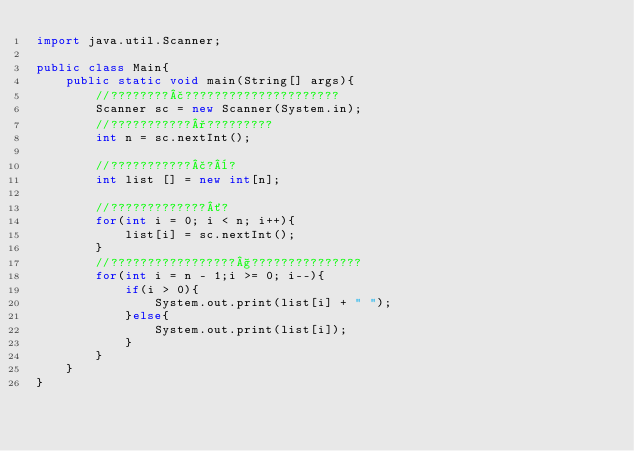<code> <loc_0><loc_0><loc_500><loc_500><_Java_>import java.util.Scanner;

public class Main{
	public static void main(String[] args){
		//????????£?????????????????????
		Scanner sc = new Scanner(System.in);
		//???????????°?????????
		int n = sc.nextInt();

		//???????????£?¨?
		int list [] = new int[n];

		//?????????????´?
		for(int i = 0; i < n; i++){
			list[i] = sc.nextInt();
		}
		//?????????????????§???????????????
		for(int i = n - 1;i >= 0; i--){
			if(i > 0){
				System.out.print(list[i] + " ");
			}else{
				System.out.print(list[i]);
			}
		}
	}
}</code> 